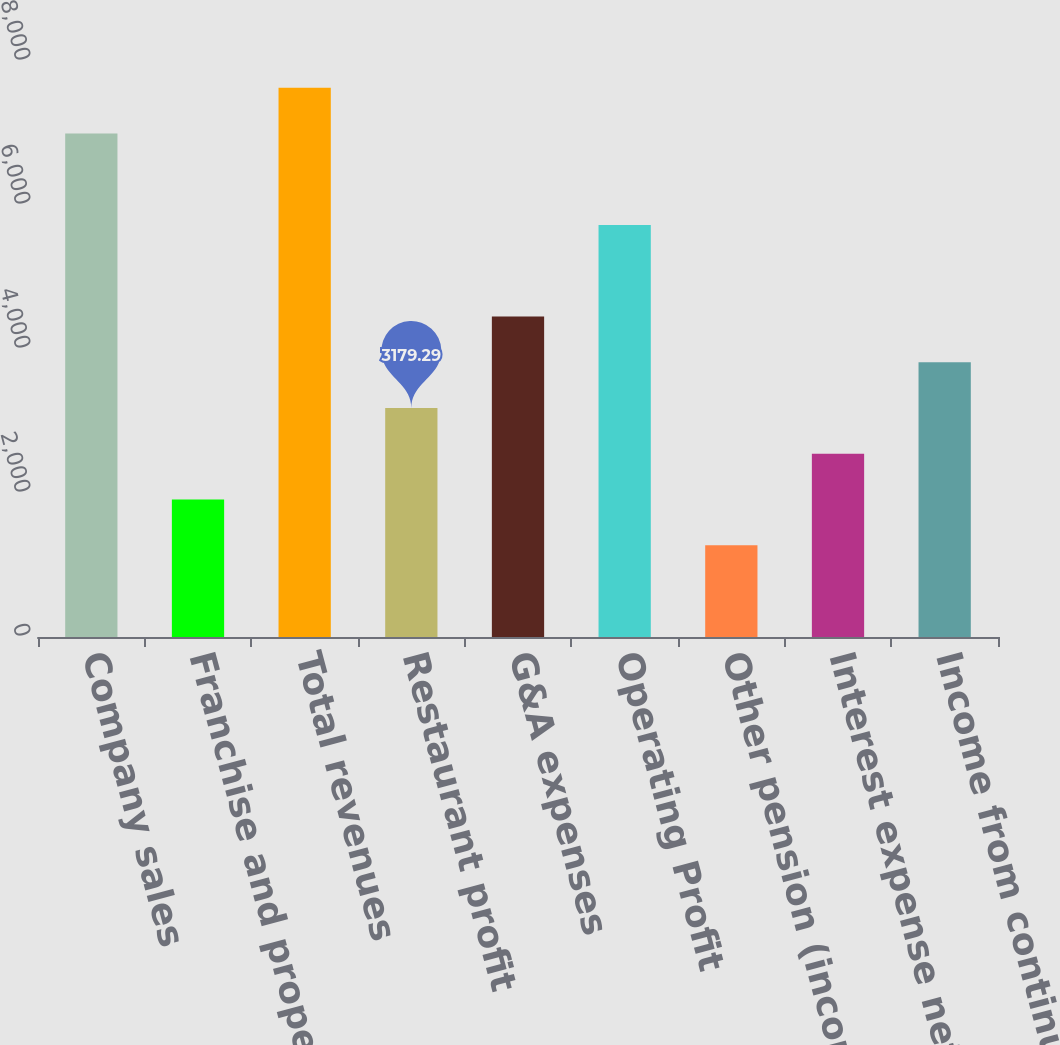Convert chart to OTSL. <chart><loc_0><loc_0><loc_500><loc_500><bar_chart><fcel>Company sales<fcel>Franchise and property<fcel>Total revenues<fcel>Restaurant profit<fcel>G&A expenses<fcel>Operating Profit<fcel>Other pension (income) expense<fcel>Interest expense net<fcel>Income from continuing<nl><fcel>6991.39<fcel>1908.59<fcel>7626.74<fcel>3179.29<fcel>4449.99<fcel>5720.69<fcel>1273.24<fcel>2543.94<fcel>3814.64<nl></chart> 